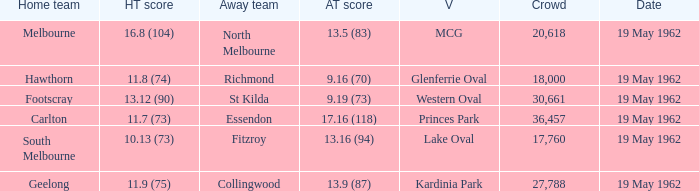What is the home team's score at mcg? 16.8 (104). Would you be able to parse every entry in this table? {'header': ['Home team', 'HT score', 'Away team', 'AT score', 'V', 'Crowd', 'Date'], 'rows': [['Melbourne', '16.8 (104)', 'North Melbourne', '13.5 (83)', 'MCG', '20,618', '19 May 1962'], ['Hawthorn', '11.8 (74)', 'Richmond', '9.16 (70)', 'Glenferrie Oval', '18,000', '19 May 1962'], ['Footscray', '13.12 (90)', 'St Kilda', '9.19 (73)', 'Western Oval', '30,661', '19 May 1962'], ['Carlton', '11.7 (73)', 'Essendon', '17.16 (118)', 'Princes Park', '36,457', '19 May 1962'], ['South Melbourne', '10.13 (73)', 'Fitzroy', '13.16 (94)', 'Lake Oval', '17,760', '19 May 1962'], ['Geelong', '11.9 (75)', 'Collingwood', '13.9 (87)', 'Kardinia Park', '27,788', '19 May 1962']]} 